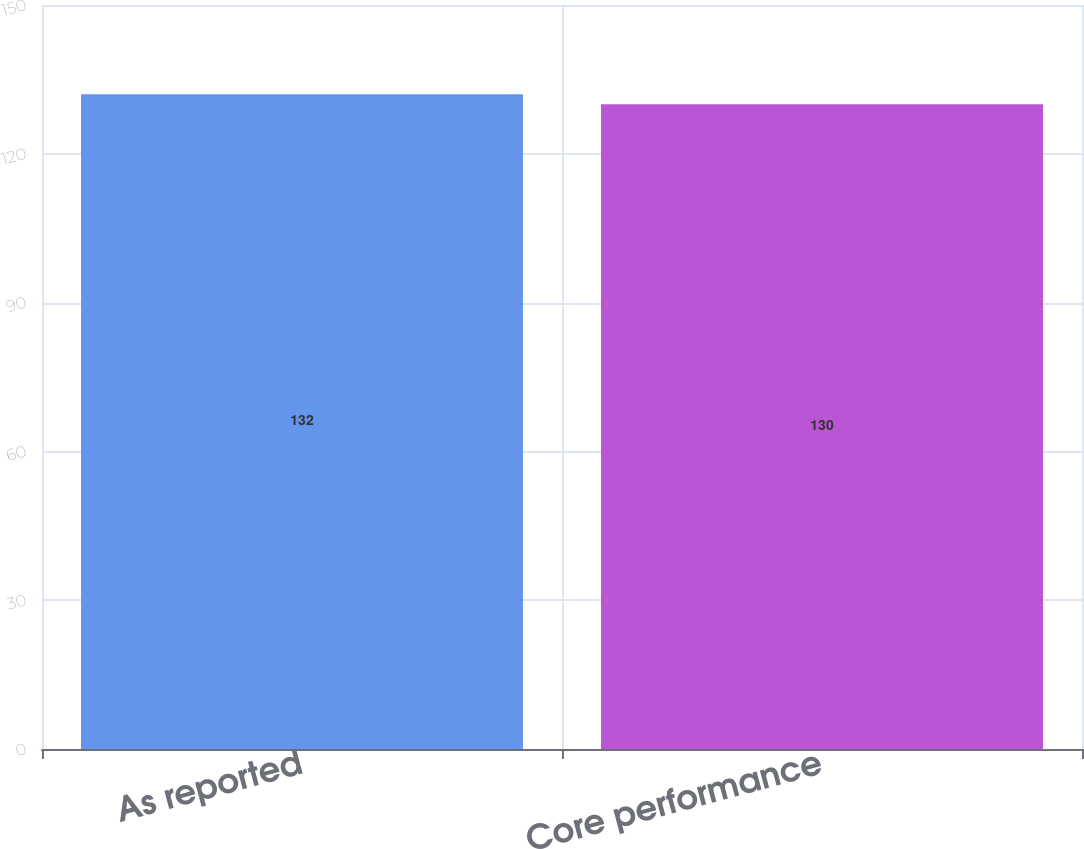<chart> <loc_0><loc_0><loc_500><loc_500><bar_chart><fcel>As reported<fcel>Core performance<nl><fcel>132<fcel>130<nl></chart> 